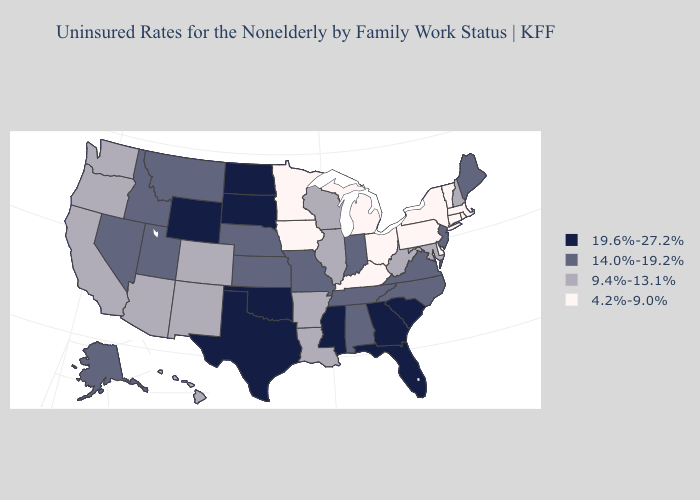Among the states that border Ohio , which have the lowest value?
Concise answer only. Kentucky, Michigan, Pennsylvania. Name the states that have a value in the range 19.6%-27.2%?
Concise answer only. Florida, Georgia, Mississippi, North Dakota, Oklahoma, South Carolina, South Dakota, Texas, Wyoming. Among the states that border Florida , does Georgia have the lowest value?
Short answer required. No. Is the legend a continuous bar?
Write a very short answer. No. Among the states that border Nevada , does Idaho have the highest value?
Give a very brief answer. Yes. Name the states that have a value in the range 9.4%-13.1%?
Give a very brief answer. Arizona, Arkansas, California, Colorado, Hawaii, Illinois, Louisiana, Maryland, New Hampshire, New Mexico, Oregon, Washington, West Virginia, Wisconsin. Which states have the lowest value in the USA?
Write a very short answer. Connecticut, Delaware, Iowa, Kentucky, Massachusetts, Michigan, Minnesota, New York, Ohio, Pennsylvania, Rhode Island, Vermont. Name the states that have a value in the range 19.6%-27.2%?
Be succinct. Florida, Georgia, Mississippi, North Dakota, Oklahoma, South Carolina, South Dakota, Texas, Wyoming. Does North Dakota have the highest value in the USA?
Be succinct. Yes. What is the lowest value in the Northeast?
Answer briefly. 4.2%-9.0%. How many symbols are there in the legend?
Keep it brief. 4. What is the value of Illinois?
Be succinct. 9.4%-13.1%. How many symbols are there in the legend?
Short answer required. 4. What is the lowest value in states that border Louisiana?
Give a very brief answer. 9.4%-13.1%. What is the value of Oklahoma?
Be succinct. 19.6%-27.2%. 